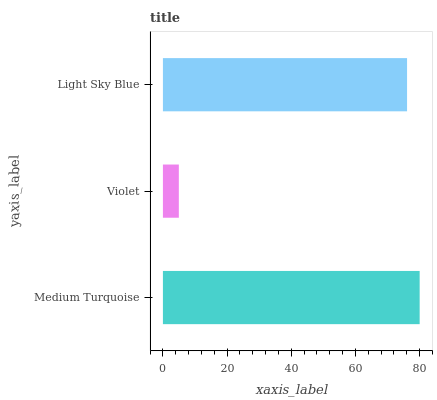Is Violet the minimum?
Answer yes or no. Yes. Is Medium Turquoise the maximum?
Answer yes or no. Yes. Is Light Sky Blue the minimum?
Answer yes or no. No. Is Light Sky Blue the maximum?
Answer yes or no. No. Is Light Sky Blue greater than Violet?
Answer yes or no. Yes. Is Violet less than Light Sky Blue?
Answer yes or no. Yes. Is Violet greater than Light Sky Blue?
Answer yes or no. No. Is Light Sky Blue less than Violet?
Answer yes or no. No. Is Light Sky Blue the high median?
Answer yes or no. Yes. Is Light Sky Blue the low median?
Answer yes or no. Yes. Is Violet the high median?
Answer yes or no. No. Is Violet the low median?
Answer yes or no. No. 